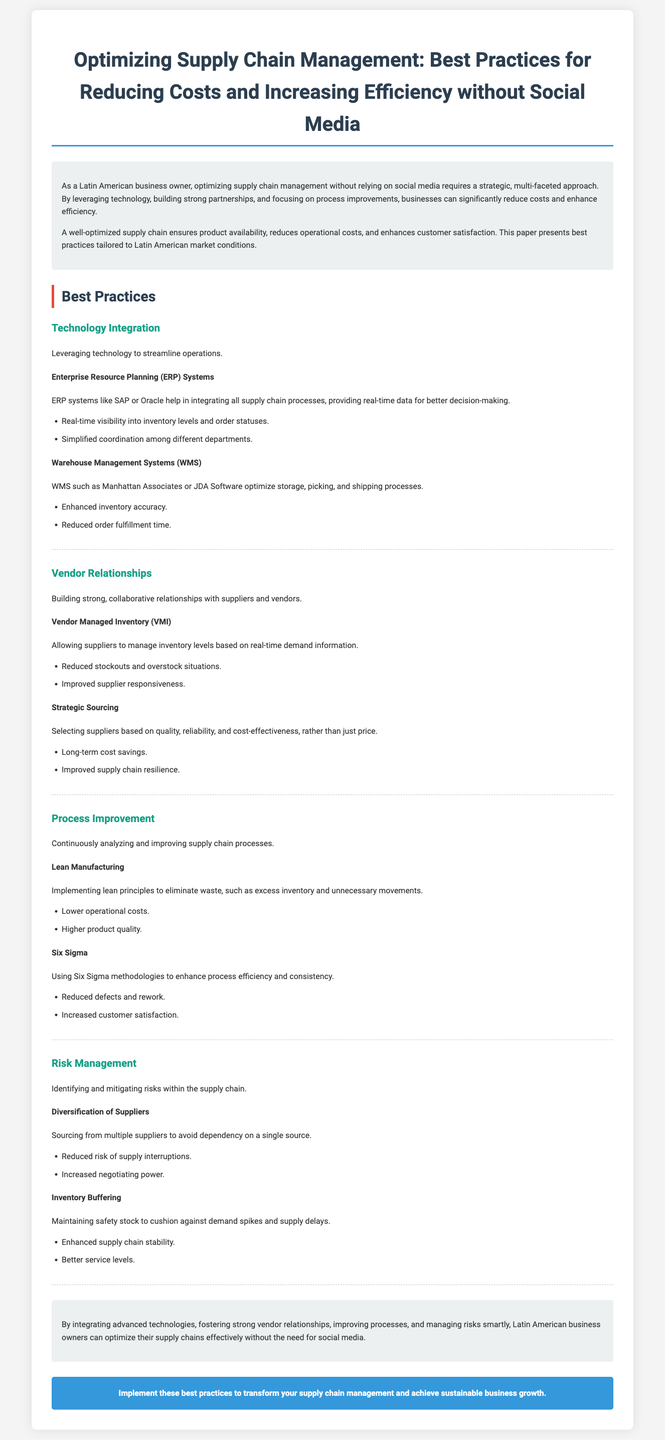What is the primary focus of the document? The primary focus of the document is on optimizing supply chain management specifically tailored for Latin American business owners, emphasizing cost reduction and efficiency without using social media.
Answer: Supply chain management What are the two types of systems mentioned for technology integration? The document lists Enterprise Resource Planning (ERP) Systems and Warehouse Management Systems (WMS) as the two types of systems for technology integration.
Answer: ERP and WMS What is one benefit of Vendor Managed Inventory (VMI)? One benefit of Vendor Managed Inventory (VMI) is that it reduces stockouts and overstock situations by allowing suppliers to manage inventory levels.
Answer: Reduced stockouts What principle does Lean Manufacturing focus on? Lean Manufacturing primarily focuses on eliminating waste within the supply chain processes.
Answer: Eliminating waste How many best practice categories are described in the document? The document describes four best practice categories to optimize supply chain management.
Answer: Four What does Six Sigma aim to reduce? Six Sigma aims to reduce defects and rework within supply chain processes.
Answer: Defects Which principle can help enhance supply chain stability? Inventory buffering is a principle that can help enhance supply chain stability by maintaining safety stock.
Answer: Inventory buffering What color theme is used for the headings in the document? The headings in the document predominantly use a color theme of dark blue and red as specified in the style section.
Answer: Dark blue and red What should business owners implement according to the conclusion? According to the conclusion, business owners should implement advanced technologies, strong vendor relationships, and improved processes.
Answer: Best practices 